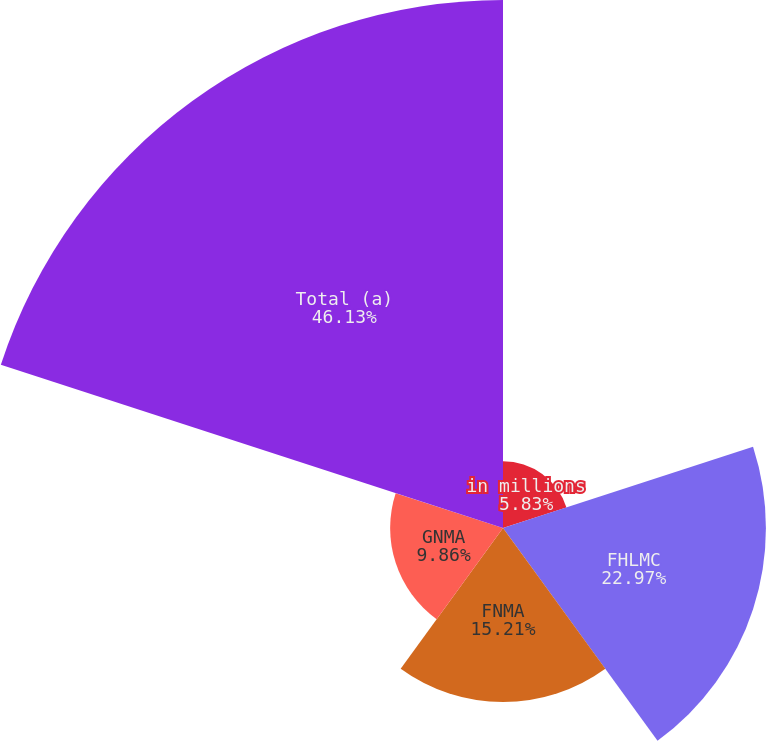Convert chart. <chart><loc_0><loc_0><loc_500><loc_500><pie_chart><fcel>in millions<fcel>FHLMC<fcel>FNMA<fcel>GNMA<fcel>Total (a)<nl><fcel>5.83%<fcel>22.97%<fcel>15.21%<fcel>9.86%<fcel>46.13%<nl></chart> 